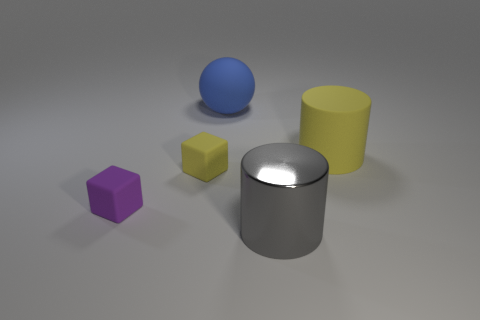Is the number of big cylinders that are behind the big metal cylinder greater than the number of large matte spheres that are in front of the large blue ball?
Ensure brevity in your answer.  Yes. What color is the big thing in front of the big rubber thing that is on the right side of the large blue thing?
Offer a very short reply. Gray. Is there a block of the same color as the large rubber cylinder?
Provide a succinct answer. Yes. What is the size of the yellow rubber thing left of the large rubber object behind the yellow matte object that is to the right of the gray shiny object?
Keep it short and to the point. Small. The small purple rubber object is what shape?
Offer a very short reply. Cube. What size is the object that is the same color as the rubber cylinder?
Offer a terse response. Small. There is a big rubber cylinder on the right side of the big blue thing; what number of large yellow matte cylinders are in front of it?
Offer a terse response. 0. How many other things are there of the same material as the blue object?
Make the answer very short. 3. Do the cylinder behind the yellow cube and the tiny block behind the tiny purple thing have the same material?
Provide a succinct answer. Yes. Is there anything else that has the same shape as the large yellow object?
Give a very brief answer. Yes. 